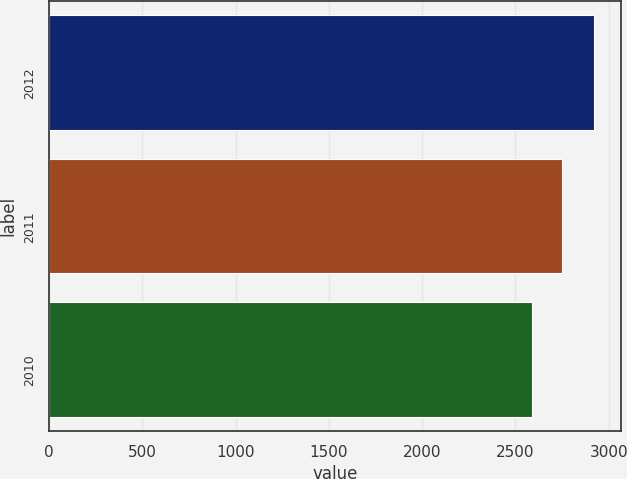<chart> <loc_0><loc_0><loc_500><loc_500><bar_chart><fcel>2012<fcel>2011<fcel>2010<nl><fcel>2921.9<fcel>2749.3<fcel>2589.2<nl></chart> 